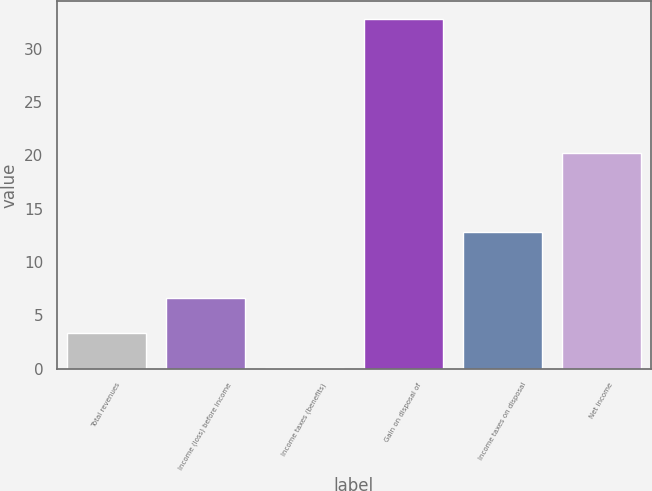<chart> <loc_0><loc_0><loc_500><loc_500><bar_chart><fcel>Total revenues<fcel>Income (loss) before income<fcel>Income taxes (benefits)<fcel>Gain on disposal of<fcel>Income taxes on disposal<fcel>Net income<nl><fcel>3.37<fcel>6.64<fcel>0.1<fcel>32.8<fcel>12.8<fcel>20.2<nl></chart> 